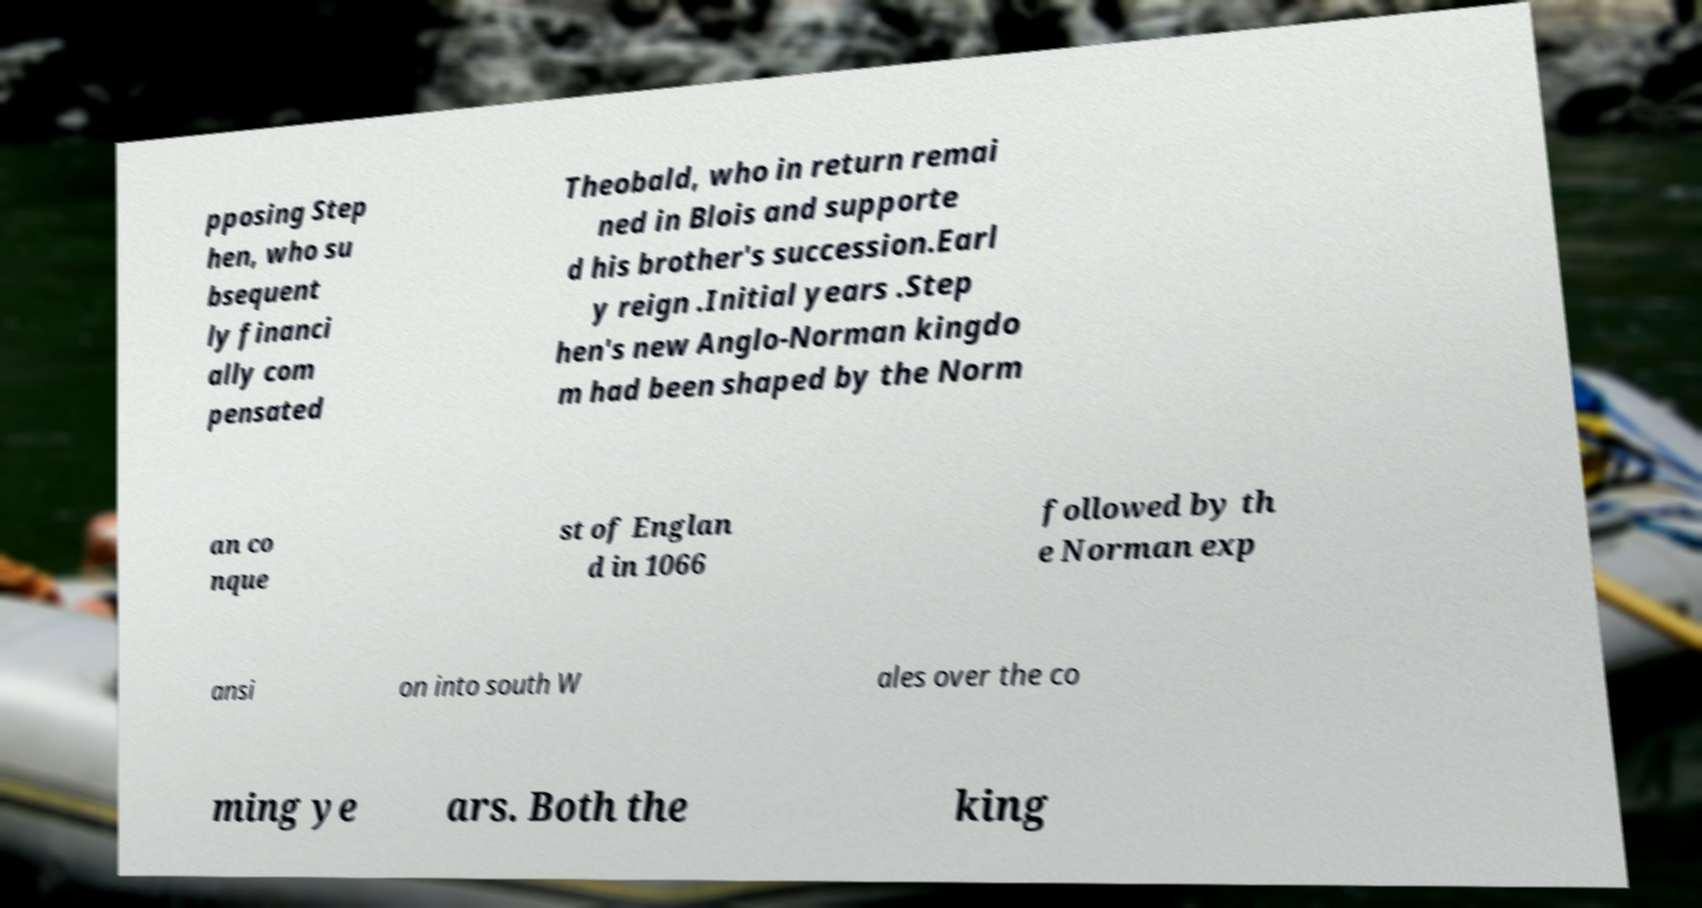Could you assist in decoding the text presented in this image and type it out clearly? pposing Step hen, who su bsequent ly financi ally com pensated Theobald, who in return remai ned in Blois and supporte d his brother's succession.Earl y reign .Initial years .Step hen's new Anglo-Norman kingdo m had been shaped by the Norm an co nque st of Englan d in 1066 followed by th e Norman exp ansi on into south W ales over the co ming ye ars. Both the king 